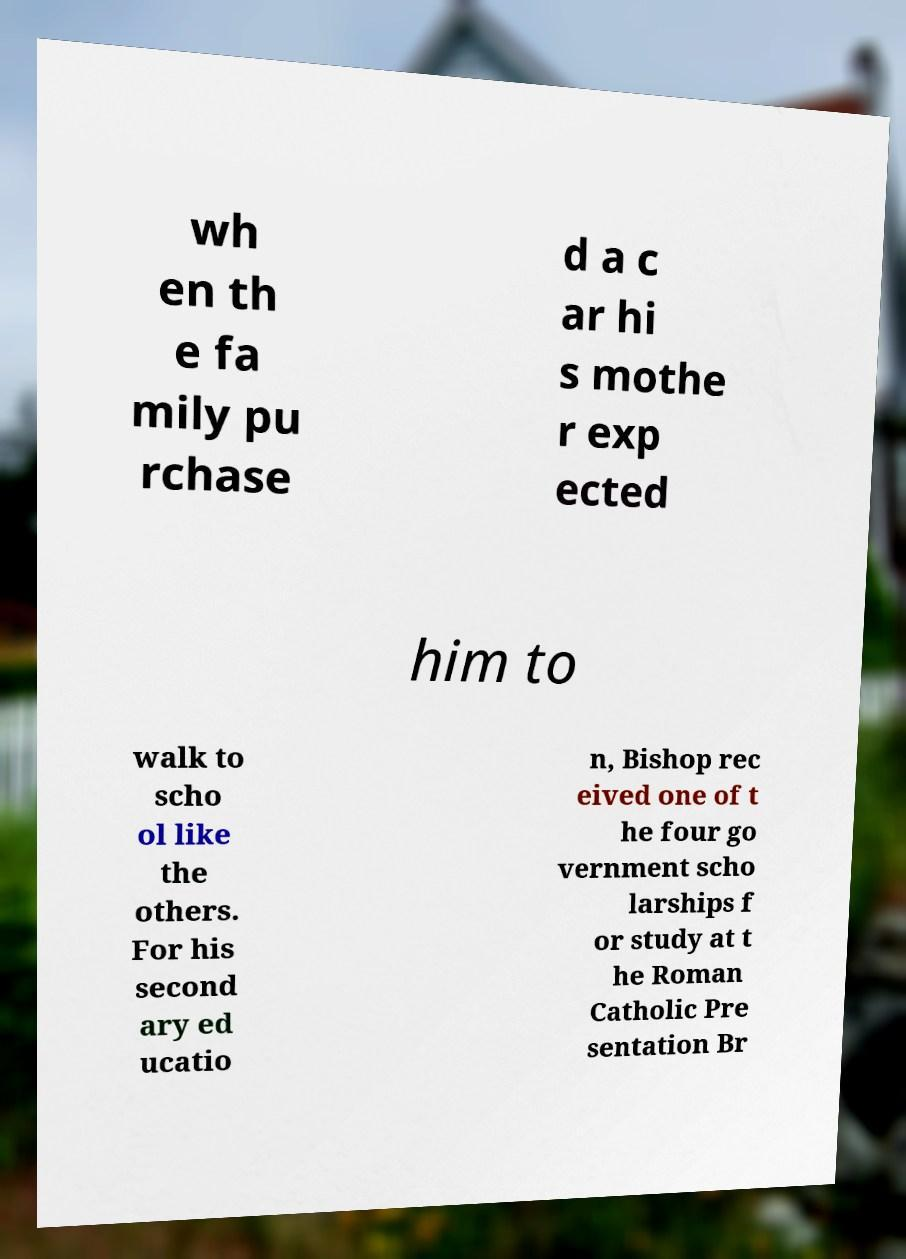Can you read and provide the text displayed in the image?This photo seems to have some interesting text. Can you extract and type it out for me? wh en th e fa mily pu rchase d a c ar hi s mothe r exp ected him to walk to scho ol like the others. For his second ary ed ucatio n, Bishop rec eived one of t he four go vernment scho larships f or study at t he Roman Catholic Pre sentation Br 